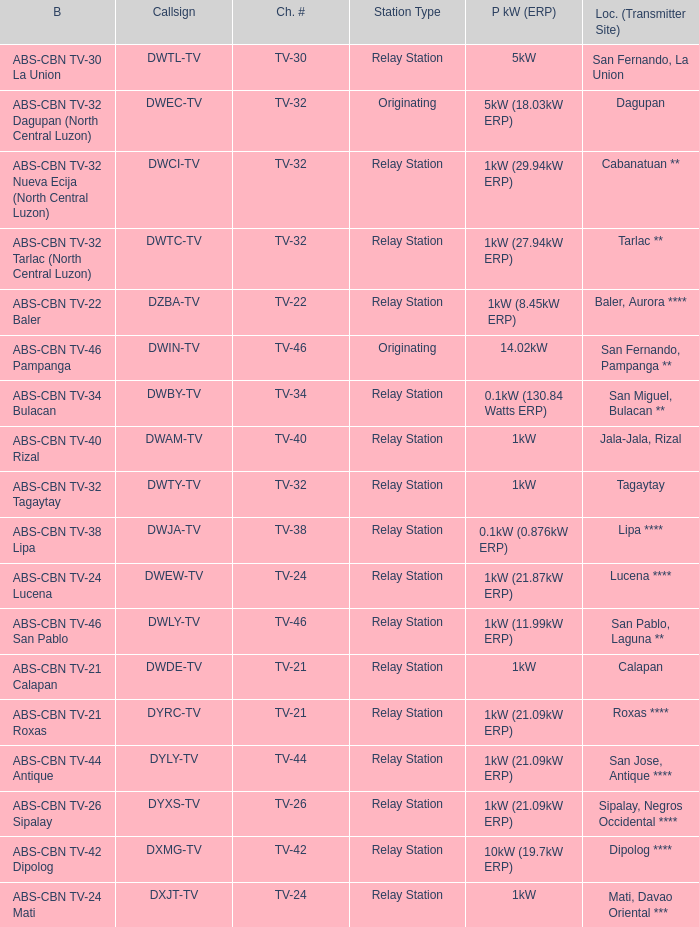The location (transmitter site) San Fernando, Pampanga ** has what Power kW (ERP)? 14.02kW. 